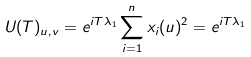<formula> <loc_0><loc_0><loc_500><loc_500>U ( T ) _ { u , v } = e ^ { i T \lambda _ { 1 } } \sum _ { i = 1 } ^ { n } x _ { i } ( u ) ^ { 2 } = e ^ { i T \lambda _ { 1 } }</formula> 